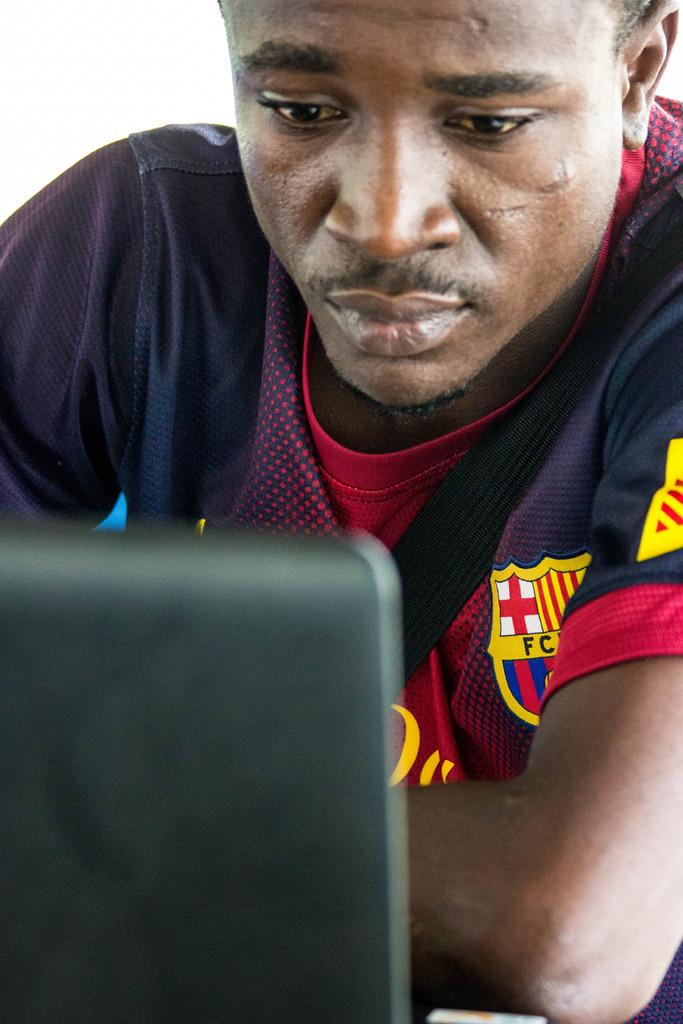Provide a one-sentence caption for the provided image. A man looks at a laptop while wearing a shirt on which the letters F and C are on the left chest. 